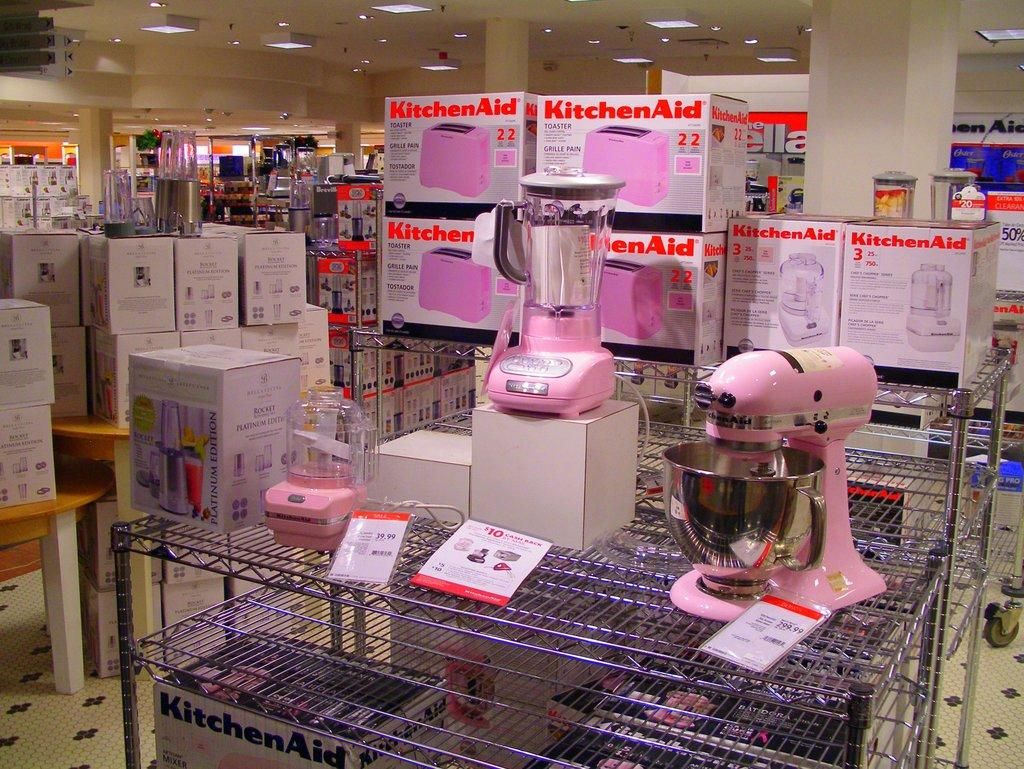What is the main subject in the center of the image? There are blenders placed on a stand in the center of the image. What can be seen in the background of the image? There are carton boxes, pillars, and blinds in the background. Where is the table located in the image? The table is on the left side of the image. What type of jeans is being used to plough the field in the image? There are no jeans or ploughs present in the image; it features blenders on a stand, carton boxes, pillars, blinds, and a table. 